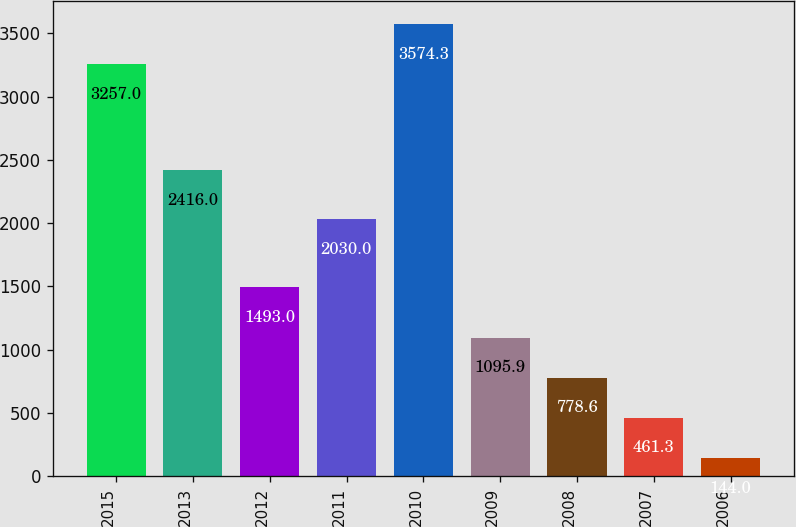Convert chart. <chart><loc_0><loc_0><loc_500><loc_500><bar_chart><fcel>2015<fcel>2013<fcel>2012<fcel>2011<fcel>2010<fcel>2009<fcel>2008<fcel>2007<fcel>2006<nl><fcel>3257<fcel>2416<fcel>1493<fcel>2030<fcel>3574.3<fcel>1095.9<fcel>778.6<fcel>461.3<fcel>144<nl></chart> 